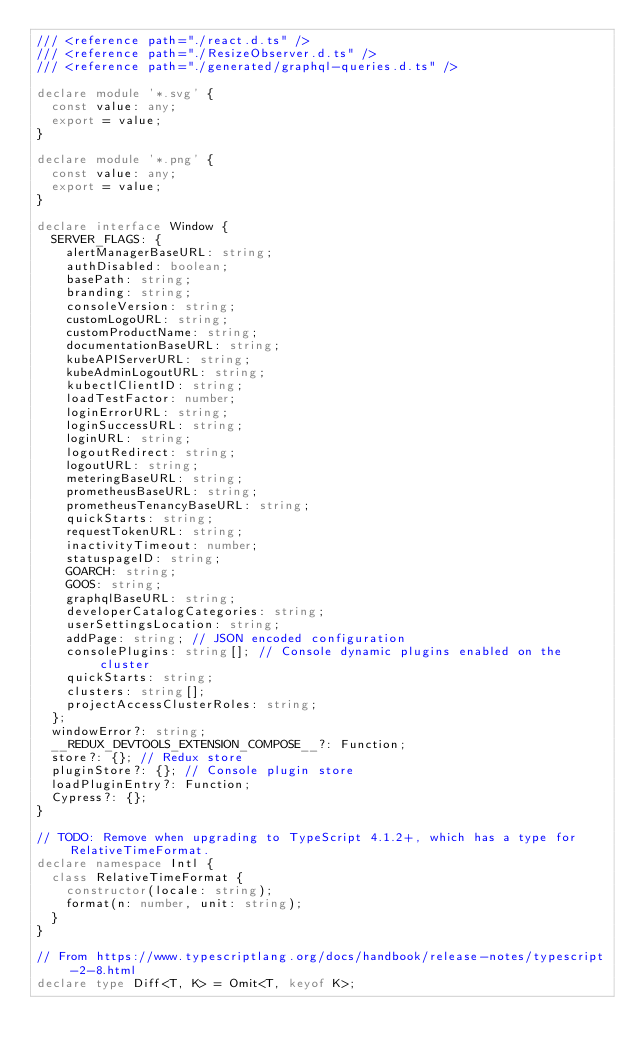<code> <loc_0><loc_0><loc_500><loc_500><_TypeScript_>/// <reference path="./react.d.ts" />
/// <reference path="./ResizeObserver.d.ts" />
/// <reference path="./generated/graphql-queries.d.ts" />

declare module '*.svg' {
  const value: any;
  export = value;
}

declare module '*.png' {
  const value: any;
  export = value;
}

declare interface Window {
  SERVER_FLAGS: {
    alertManagerBaseURL: string;
    authDisabled: boolean;
    basePath: string;
    branding: string;
    consoleVersion: string;
    customLogoURL: string;
    customProductName: string;
    documentationBaseURL: string;
    kubeAPIServerURL: string;
    kubeAdminLogoutURL: string;
    kubectlClientID: string;
    loadTestFactor: number;
    loginErrorURL: string;
    loginSuccessURL: string;
    loginURL: string;
    logoutRedirect: string;
    logoutURL: string;
    meteringBaseURL: string;
    prometheusBaseURL: string;
    prometheusTenancyBaseURL: string;
    quickStarts: string;
    requestTokenURL: string;
    inactivityTimeout: number;
    statuspageID: string;
    GOARCH: string;
    GOOS: string;
    graphqlBaseURL: string;
    developerCatalogCategories: string;
    userSettingsLocation: string;
    addPage: string; // JSON encoded configuration
    consolePlugins: string[]; // Console dynamic plugins enabled on the cluster
    quickStarts: string;
    clusters: string[];
    projectAccessClusterRoles: string;
  };
  windowError?: string;
  __REDUX_DEVTOOLS_EXTENSION_COMPOSE__?: Function;
  store?: {}; // Redux store
  pluginStore?: {}; // Console plugin store
  loadPluginEntry?: Function;
  Cypress?: {};
}

// TODO: Remove when upgrading to TypeScript 4.1.2+, which has a type for RelativeTimeFormat.
declare namespace Intl {
  class RelativeTimeFormat {
    constructor(locale: string);
    format(n: number, unit: string);
  }
}

// From https://www.typescriptlang.org/docs/handbook/release-notes/typescript-2-8.html
declare type Diff<T, K> = Omit<T, keyof K>;
</code> 